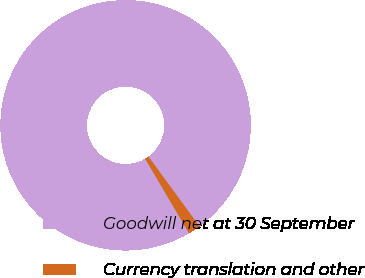<chart> <loc_0><loc_0><loc_500><loc_500><pie_chart><fcel>Goodwill net at 30 September<fcel>Currency translation and other<nl><fcel>98.42%<fcel>1.58%<nl></chart> 